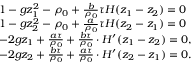Convert formula to latex. <formula><loc_0><loc_0><loc_500><loc_500>\begin{array} { r l } & { 1 - g z _ { 1 } ^ { 2 } - \rho _ { 0 } + \frac { b } { \rho _ { 0 } } \tau H ( z _ { 1 } - z _ { 2 } ) = 0 } \\ & { 1 - g z _ { 2 } ^ { 2 } - \rho _ { 0 } + \frac { a } { \rho _ { 0 } } \tau H ( z _ { 2 } - z _ { 1 } ) = 0 } \\ & { - 2 g z _ { 1 } + \frac { a \tau } { \rho _ { 0 } } + \frac { b \tau } { \rho _ { 0 } } \cdot H ^ { \prime } ( z _ { 1 } - z _ { 2 } ) = 0 , } \\ & { - 2 g z _ { 2 } + \frac { b \tau } { \rho _ { 0 } } + \frac { a \tau } { \rho _ { 0 } } \cdot H ^ { \prime } ( z _ { 2 } - z _ { 1 } ) = 0 . } \end{array}</formula> 